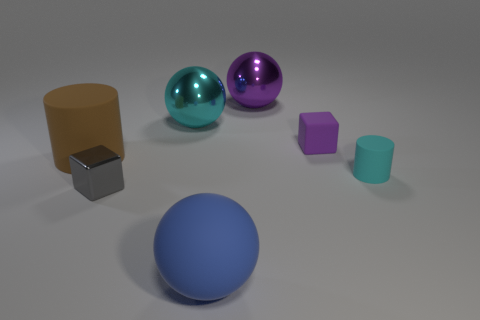The large matte cylinder is what color?
Your answer should be compact. Brown. What is the big thing that is to the left of the gray thing made of?
Ensure brevity in your answer.  Rubber. Is the shape of the big cyan shiny thing the same as the blue rubber object in front of the large cylinder?
Your response must be concise. Yes. Are there more cyan shiny balls than small green matte cubes?
Give a very brief answer. Yes. Are there any other things that are the same color as the small matte cube?
Your answer should be compact. Yes. What is the shape of the tiny purple object that is made of the same material as the tiny cyan cylinder?
Provide a succinct answer. Cube. There is a tiny cyan cylinder in front of the metallic ball on the left side of the blue object; what is it made of?
Provide a short and direct response. Rubber. There is a object to the right of the purple matte cube; is it the same shape as the purple rubber object?
Make the answer very short. No. Are there more big brown matte cylinders on the left side of the tiny matte cylinder than brown rubber things?
Make the answer very short. No. Is there any other thing that has the same material as the large cylinder?
Offer a terse response. Yes. 